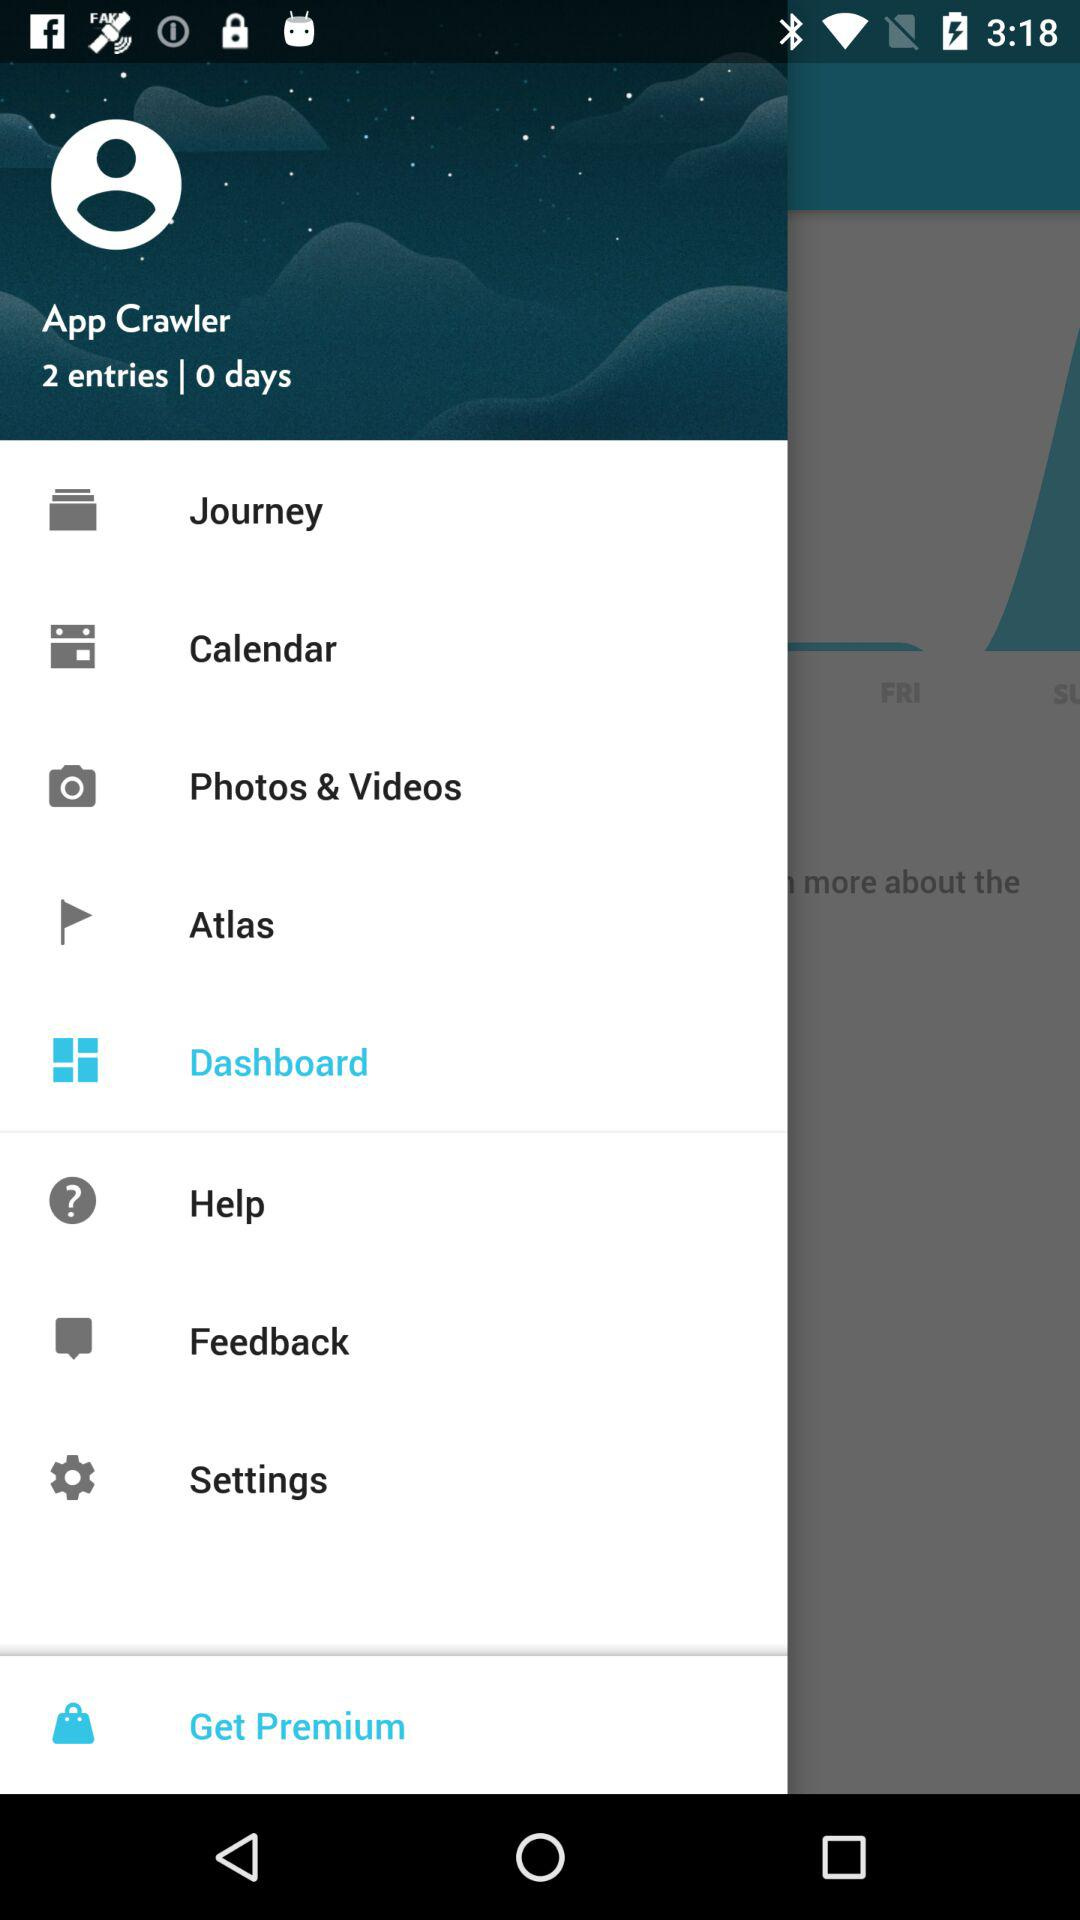How many days are there? There are 0 days. 